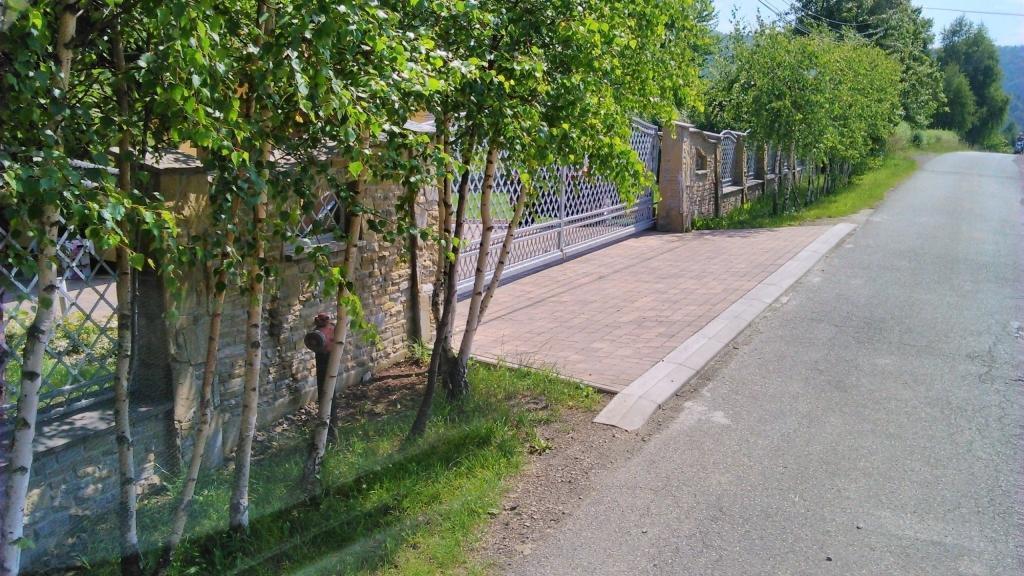Could you give a brief overview of what you see in this image? In this image I can see grass, trees, fence, fire hydrant, mountains and the sky. This image is taken may be during a day. 